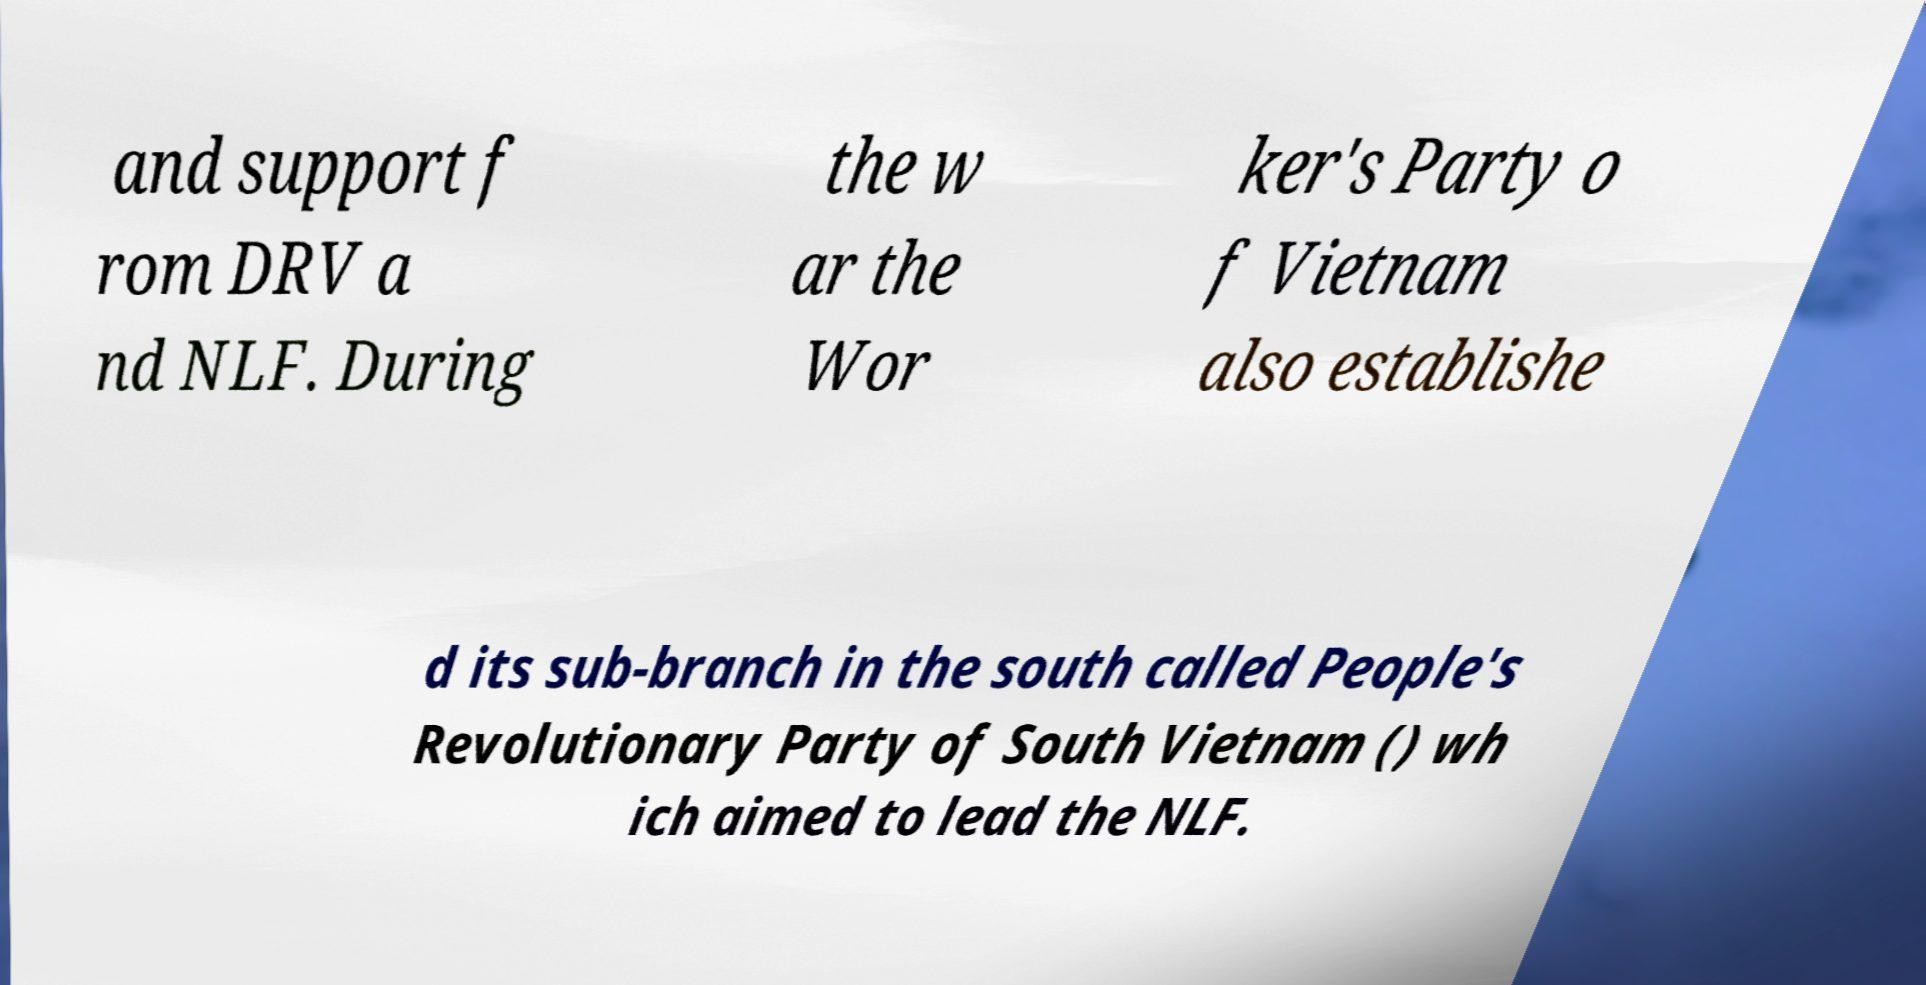Please identify and transcribe the text found in this image. and support f rom DRV a nd NLF. During the w ar the Wor ker's Party o f Vietnam also establishe d its sub-branch in the south called People's Revolutionary Party of South Vietnam () wh ich aimed to lead the NLF. 